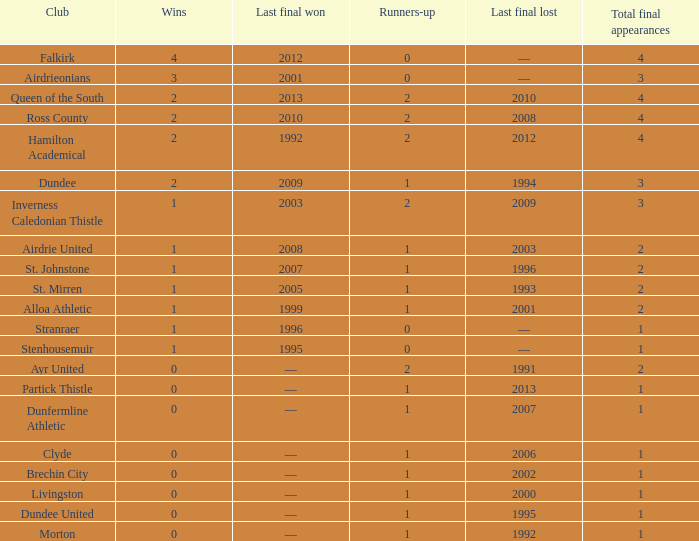What club has over 1 runners-up and last won the final in 2010? Ross County. 